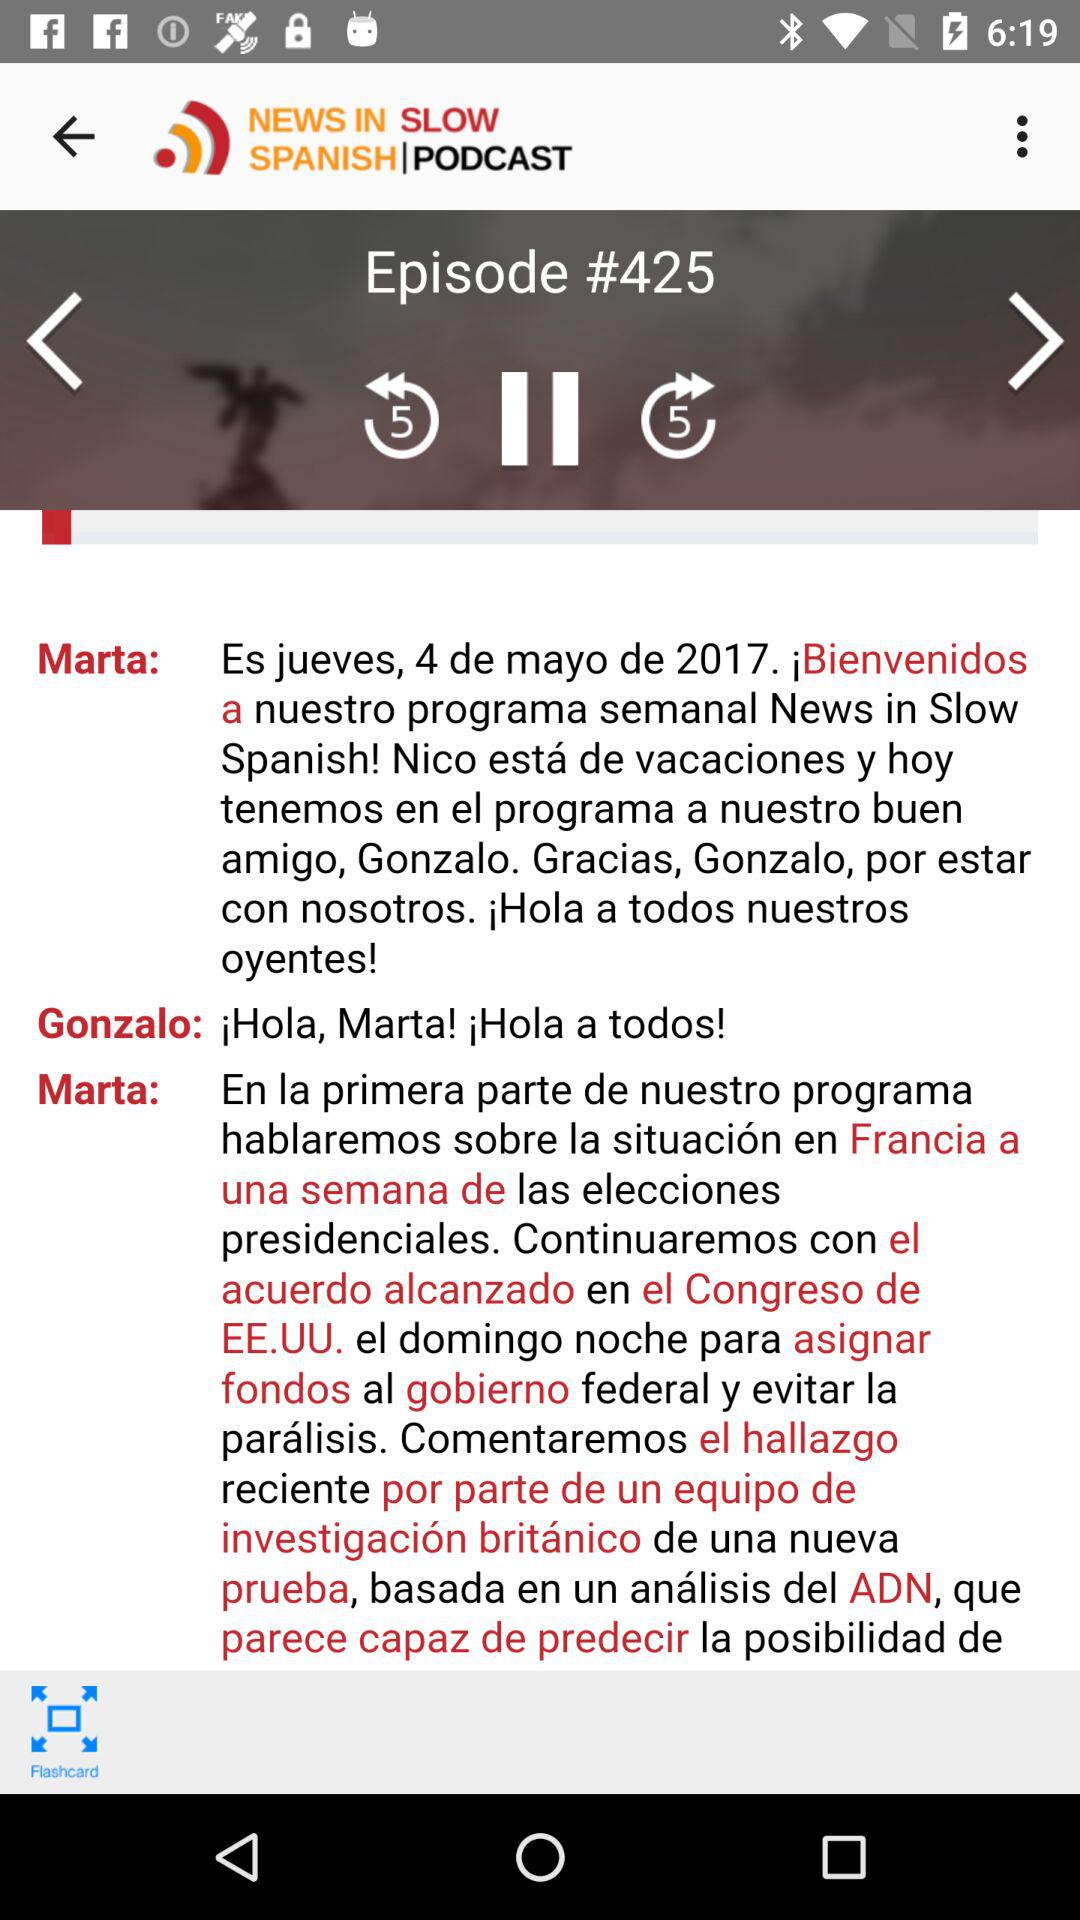What is the app name? The app name is "NEWS IN SLOW SPANISH|PODCAST". 